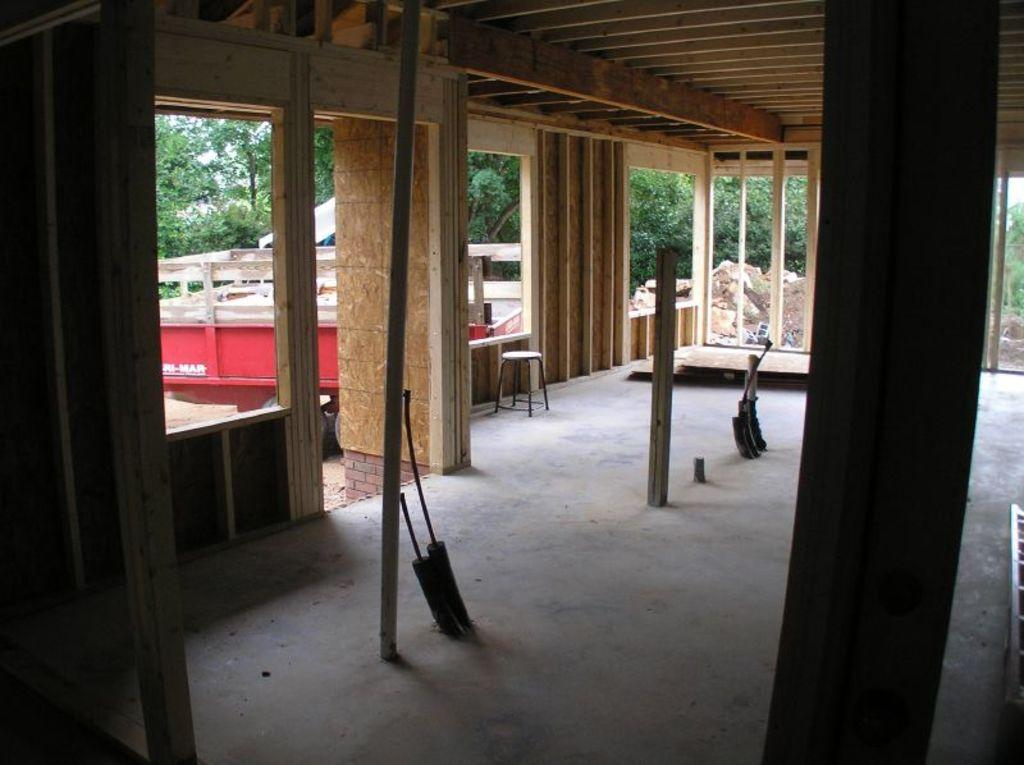What type of space is depicted in the image? There is a room in the image. What architectural features can be seen in the room? There are pillars in the room. What else is present in the room besides the pillars? There are objects in the room. What can be seen outside of the room in the image? Trees and a vehicle are visible in the image. What is the ground made of in the image? Sand is present in the image. What other elements can be found on the ground? Stones are visible in the image. What type of shelter is present in the image? There is a tent in the image. What type of insect can be seen using its fang to open the tent in the image? There are no insects present in the image, let alone one using its fang to open the tent. 